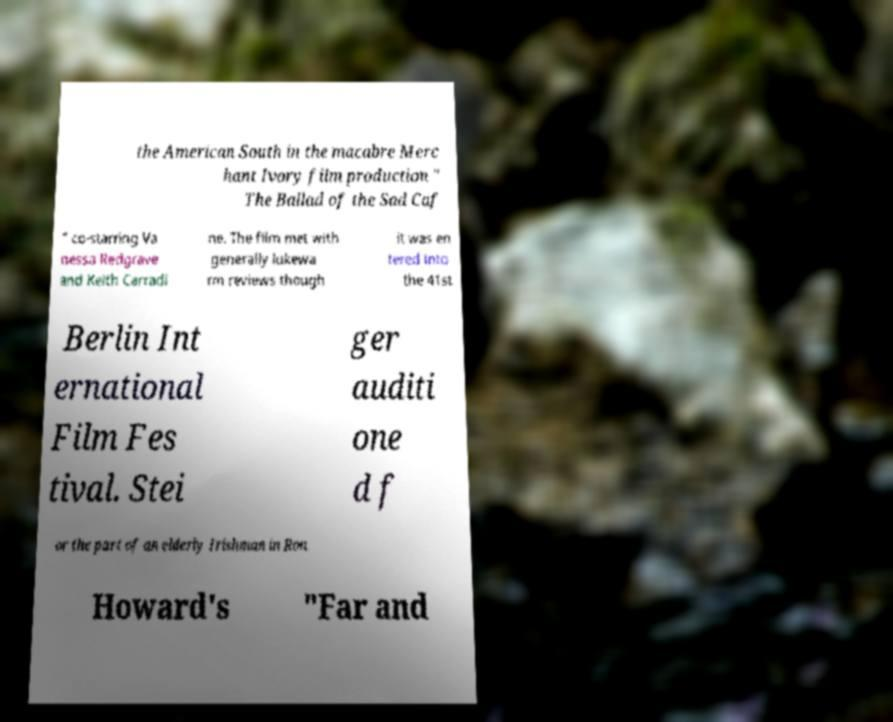Please identify and transcribe the text found in this image. the American South in the macabre Merc hant Ivory film production " The Ballad of the Sad Caf " co-starring Va nessa Redgrave and Keith Carradi ne. The film met with generally lukewa rm reviews though it was en tered into the 41st Berlin Int ernational Film Fes tival. Stei ger auditi one d f or the part of an elderly Irishman in Ron Howard's "Far and 